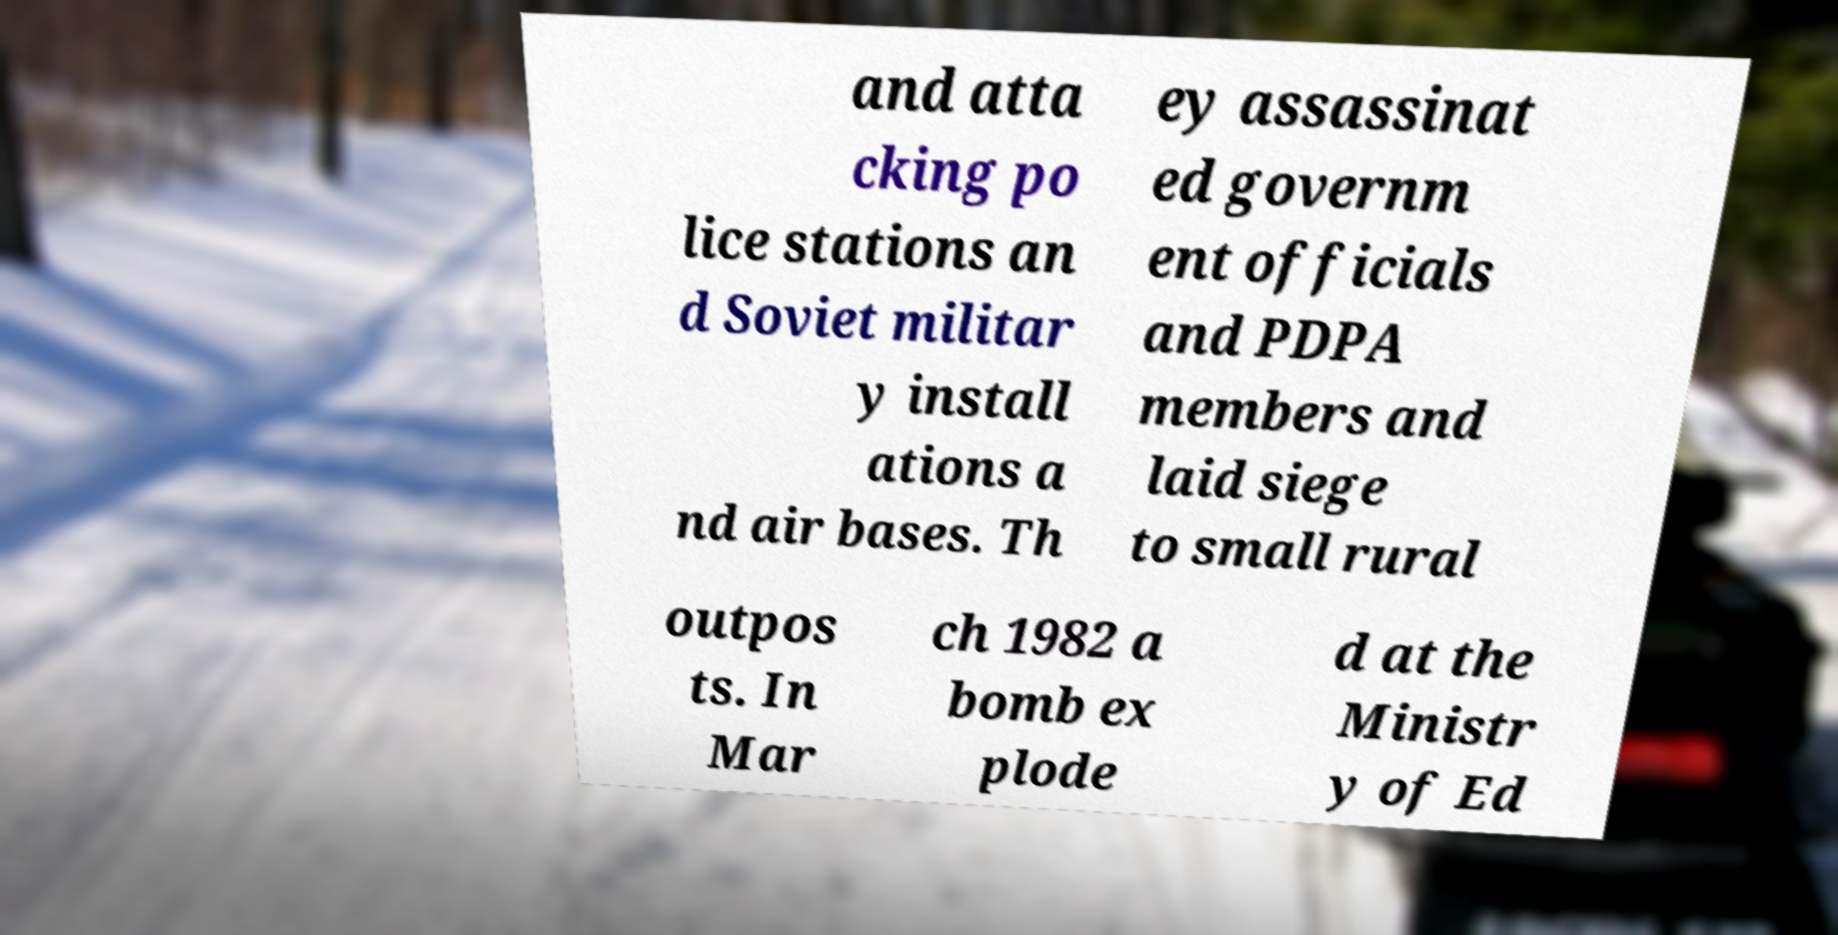Please identify and transcribe the text found in this image. and atta cking po lice stations an d Soviet militar y install ations a nd air bases. Th ey assassinat ed governm ent officials and PDPA members and laid siege to small rural outpos ts. In Mar ch 1982 a bomb ex plode d at the Ministr y of Ed 